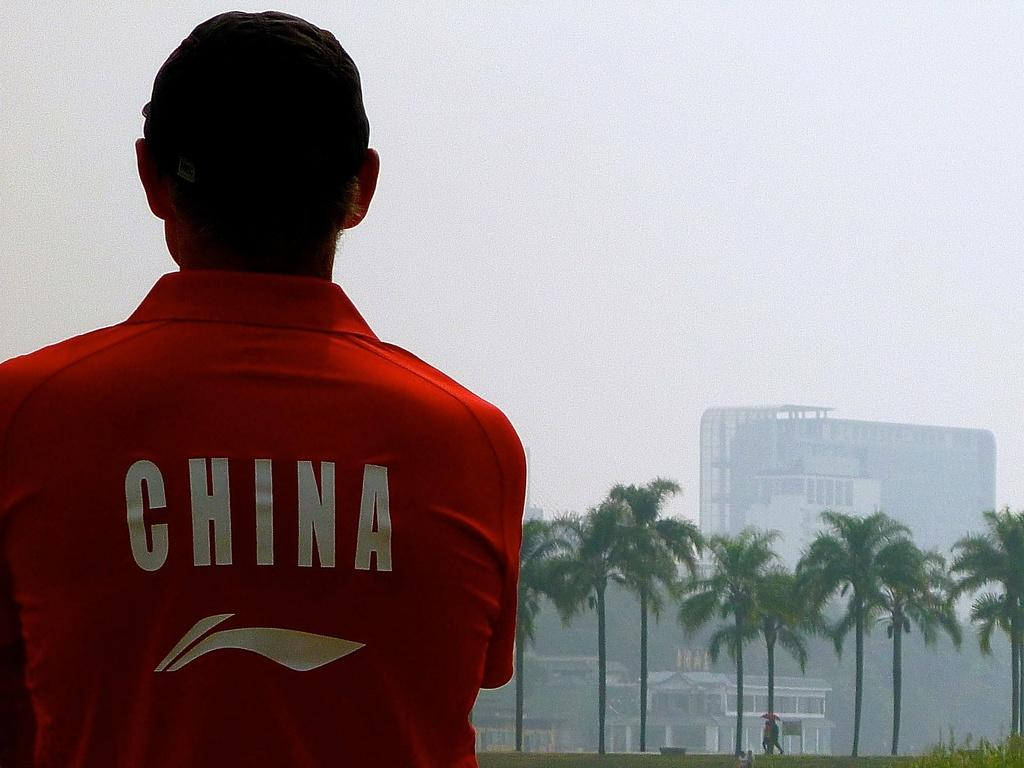<image>
Write a terse but informative summary of the picture. a man wearing a red shirt that says 'china' on the back of it 